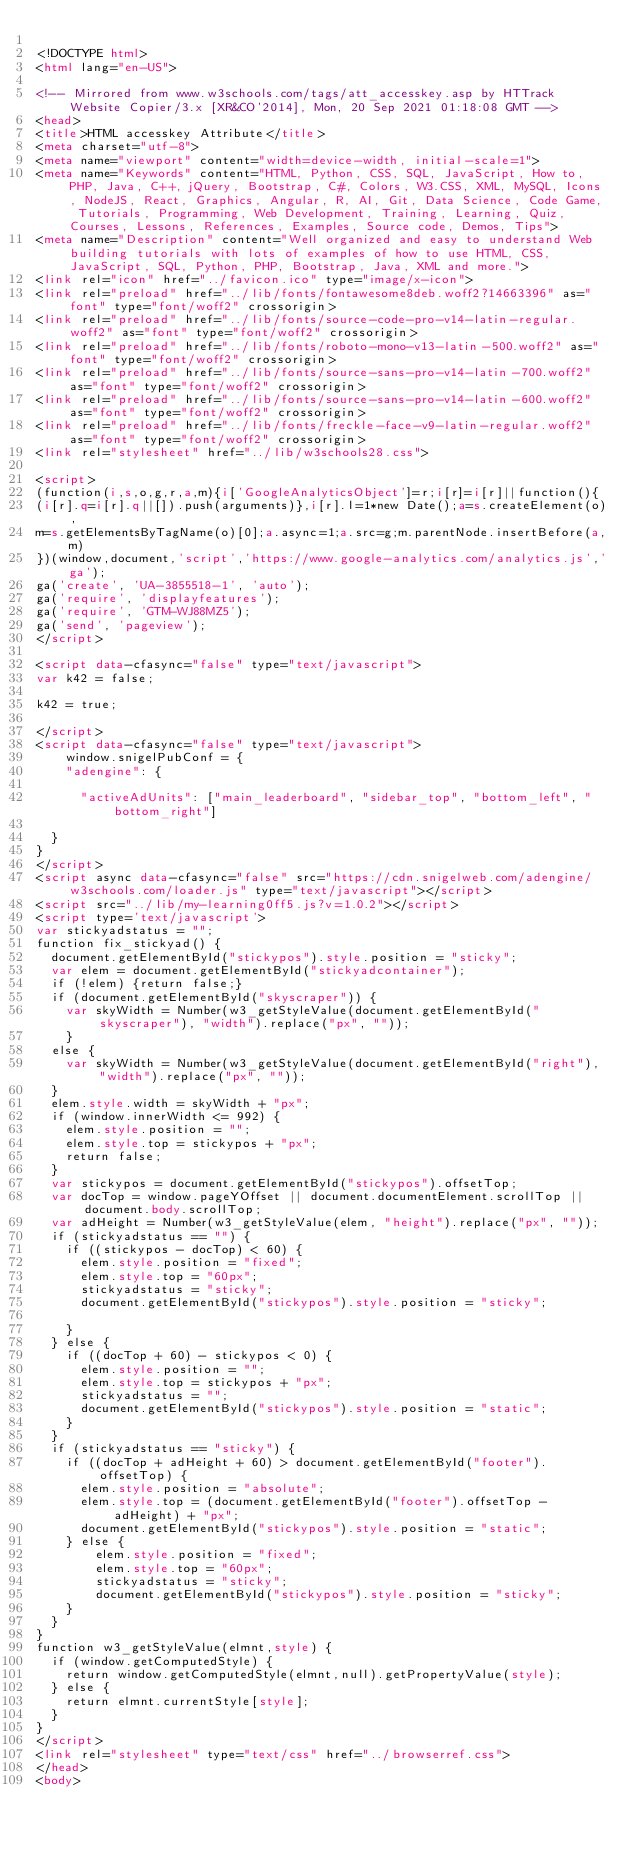<code> <loc_0><loc_0><loc_500><loc_500><_HTML_>
<!DOCTYPE html>
<html lang="en-US">

<!-- Mirrored from www.w3schools.com/tags/att_accesskey.asp by HTTrack Website Copier/3.x [XR&CO'2014], Mon, 20 Sep 2021 01:18:08 GMT -->
<head>
<title>HTML accesskey Attribute</title>
<meta charset="utf-8">
<meta name="viewport" content="width=device-width, initial-scale=1">
<meta name="Keywords" content="HTML, Python, CSS, SQL, JavaScript, How to, PHP, Java, C++, jQuery, Bootstrap, C#, Colors, W3.CSS, XML, MySQL, Icons, NodeJS, React, Graphics, Angular, R, AI, Git, Data Science, Code Game, Tutorials, Programming, Web Development, Training, Learning, Quiz, Courses, Lessons, References, Examples, Source code, Demos, Tips">
<meta name="Description" content="Well organized and easy to understand Web building tutorials with lots of examples of how to use HTML, CSS, JavaScript, SQL, Python, PHP, Bootstrap, Java, XML and more.">
<link rel="icon" href="../favicon.ico" type="image/x-icon">
<link rel="preload" href="../lib/fonts/fontawesome8deb.woff2?14663396" as="font" type="font/woff2" crossorigin> 
<link rel="preload" href="../lib/fonts/source-code-pro-v14-latin-regular.woff2" as="font" type="font/woff2" crossorigin> 
<link rel="preload" href="../lib/fonts/roboto-mono-v13-latin-500.woff2" as="font" type="font/woff2" crossorigin> 
<link rel="preload" href="../lib/fonts/source-sans-pro-v14-latin-700.woff2" as="font" type="font/woff2" crossorigin> 
<link rel="preload" href="../lib/fonts/source-sans-pro-v14-latin-600.woff2" as="font" type="font/woff2" crossorigin> 
<link rel="preload" href="../lib/fonts/freckle-face-v9-latin-regular.woff2" as="font" type="font/woff2" crossorigin> 
<link rel="stylesheet" href="../lib/w3schools28.css">

<script>
(function(i,s,o,g,r,a,m){i['GoogleAnalyticsObject']=r;i[r]=i[r]||function(){
(i[r].q=i[r].q||[]).push(arguments)},i[r].l=1*new Date();a=s.createElement(o),
m=s.getElementsByTagName(o)[0];a.async=1;a.src=g;m.parentNode.insertBefore(a,m)
})(window,document,'script','https://www.google-analytics.com/analytics.js','ga');
ga('create', 'UA-3855518-1', 'auto');
ga('require', 'displayfeatures');
ga('require', 'GTM-WJ88MZ5');
ga('send', 'pageview');
</script>

<script data-cfasync="false" type="text/javascript">
var k42 = false;

k42 = true;

</script>
<script data-cfasync="false" type="text/javascript">
    window.snigelPubConf = {
    "adengine": {

      "activeAdUnits": ["main_leaderboard", "sidebar_top", "bottom_left", "bottom_right"]

  }
}
</script>
<script async data-cfasync="false" src="https://cdn.snigelweb.com/adengine/w3schools.com/loader.js" type="text/javascript"></script>
<script src="../lib/my-learning0ff5.js?v=1.0.2"></script>
<script type='text/javascript'>
var stickyadstatus = "";
function fix_stickyad() {
  document.getElementById("stickypos").style.position = "sticky";
  var elem = document.getElementById("stickyadcontainer");
  if (!elem) {return false;}
  if (document.getElementById("skyscraper")) {
    var skyWidth = Number(w3_getStyleValue(document.getElementById("skyscraper"), "width").replace("px", ""));  
    }
  else {
    var skyWidth = Number(w3_getStyleValue(document.getElementById("right"), "width").replace("px", ""));  
  }
  elem.style.width = skyWidth + "px";
  if (window.innerWidth <= 992) {
    elem.style.position = "";
    elem.style.top = stickypos + "px";
    return false;
  }
  var stickypos = document.getElementById("stickypos").offsetTop;
  var docTop = window.pageYOffset || document.documentElement.scrollTop || document.body.scrollTop;
  var adHeight = Number(w3_getStyleValue(elem, "height").replace("px", ""));
  if (stickyadstatus == "") {
    if ((stickypos - docTop) < 60) {
      elem.style.position = "fixed";
      elem.style.top = "60px";
      stickyadstatus = "sticky";
      document.getElementById("stickypos").style.position = "sticky";

    }
  } else {
    if ((docTop + 60) - stickypos < 0) {  
      elem.style.position = "";
      elem.style.top = stickypos + "px";
      stickyadstatus = "";
      document.getElementById("stickypos").style.position = "static";
    }
  }
  if (stickyadstatus == "sticky") {
    if ((docTop + adHeight + 60) > document.getElementById("footer").offsetTop) {
      elem.style.position = "absolute";
      elem.style.top = (document.getElementById("footer").offsetTop - adHeight) + "px";
      document.getElementById("stickypos").style.position = "static";
    } else {
        elem.style.position = "fixed";
        elem.style.top = "60px";
        stickyadstatus = "sticky";
        document.getElementById("stickypos").style.position = "sticky";
    }
  }
}
function w3_getStyleValue(elmnt,style) {
  if (window.getComputedStyle) {
    return window.getComputedStyle(elmnt,null).getPropertyValue(style);
  } else {
    return elmnt.currentStyle[style];
  }
}
</script>
<link rel="stylesheet" type="text/css" href="../browserref.css">
</head>
<body>
</code> 